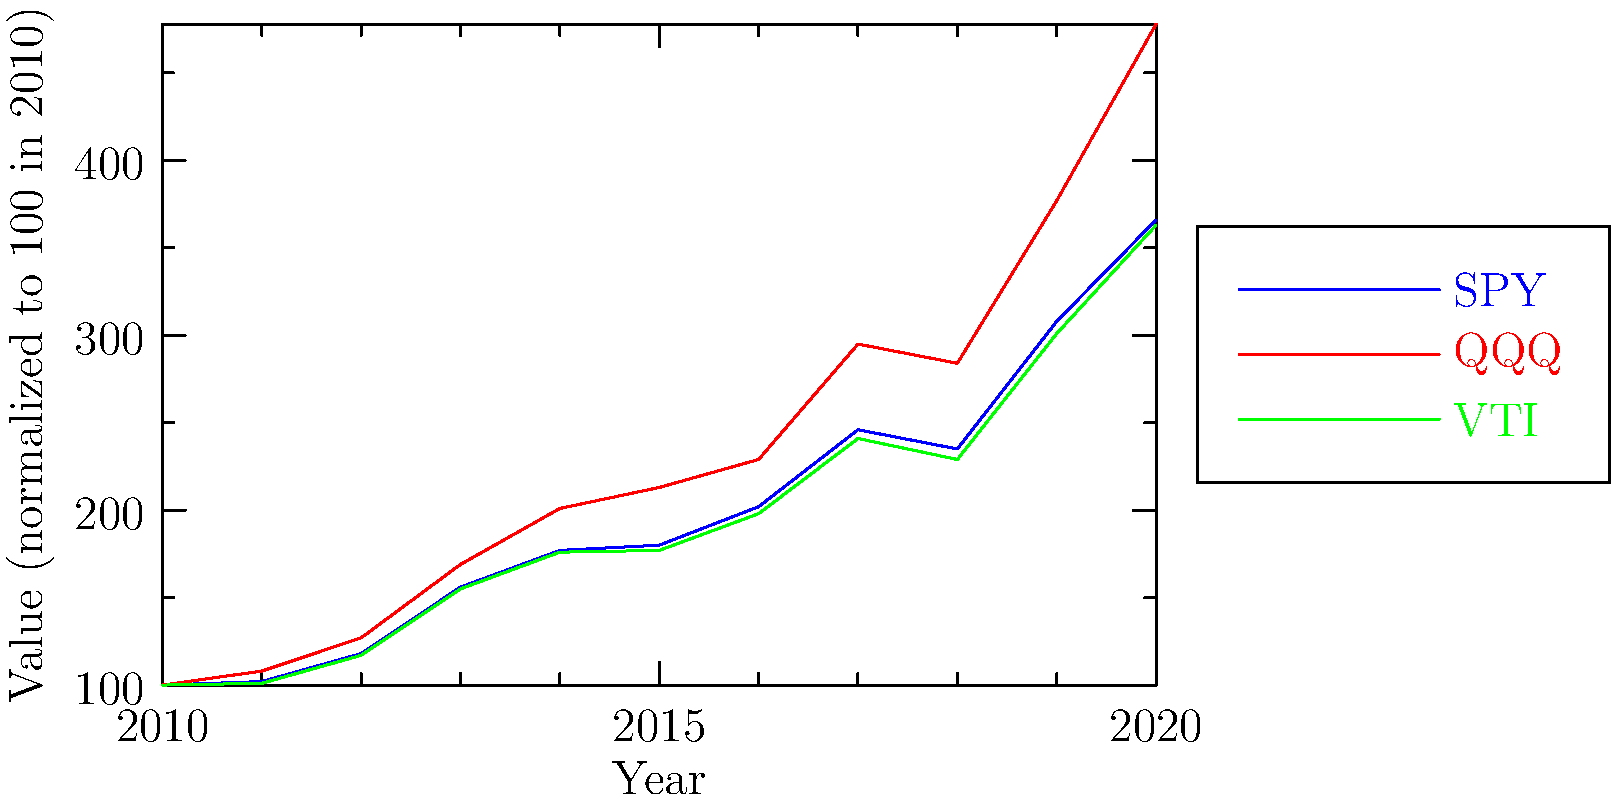Based on the line graph showing the historical performance of three ETFs (SPY, QQQ, and VTI) from 2010 to 2020, which ETF demonstrated the highest overall growth rate during this period? To determine which ETF had the highest overall growth rate, we need to compare their performance from 2010 to 2020:

1. Analyze the starting and ending points:
   - All ETFs start at 100 in 2010 (normalized value)
   - SPY ends at 366 in 2020
   - QQQ ends at 478 in 2020
   - VTI ends at 363 in 2020

2. Calculate the total growth for each ETF:
   - SPY growth: $366 - 100 = 266$ (266% increase)
   - QQQ growth: $478 - 100 = 378$ (378% increase)
   - VTI growth: $363 - 100 = 263$ (263% increase)

3. Compare the growth rates:
   QQQ has the highest growth rate at 378%, followed by SPY at 266%, and VTI at 263%.

4. Observe the graph:
   The red line (QQQ) shows the steepest upward trajectory, confirming the numerical analysis.

Therefore, QQQ demonstrated the highest overall growth rate during this period.
Answer: QQQ 